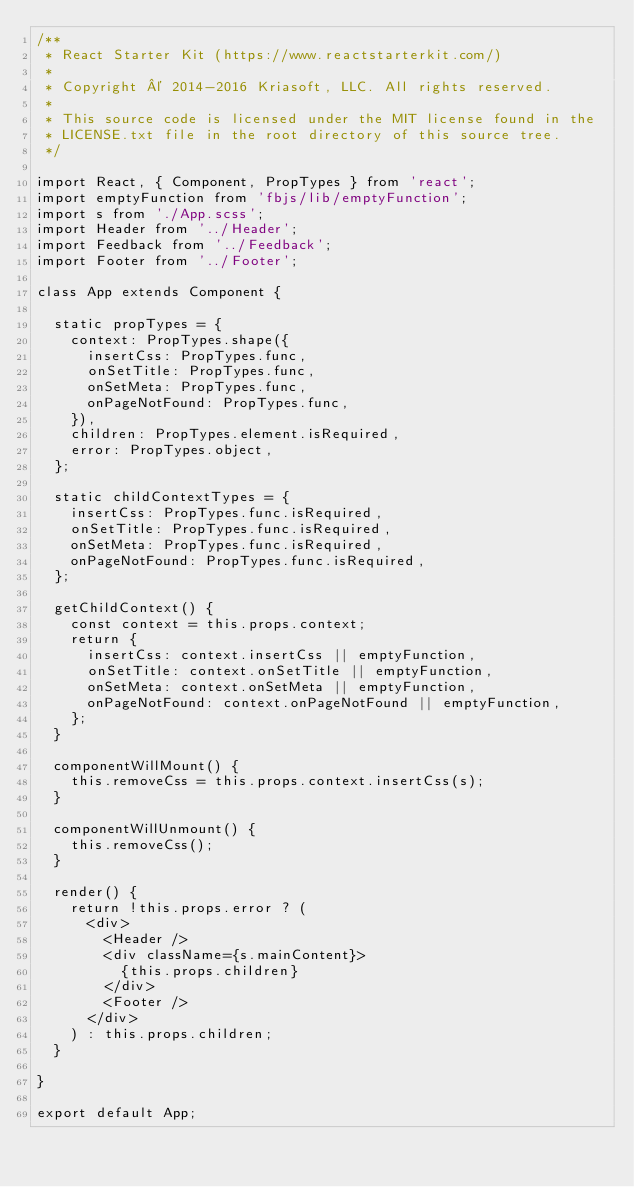<code> <loc_0><loc_0><loc_500><loc_500><_JavaScript_>/**
 * React Starter Kit (https://www.reactstarterkit.com/)
 *
 * Copyright © 2014-2016 Kriasoft, LLC. All rights reserved.
 *
 * This source code is licensed under the MIT license found in the
 * LICENSE.txt file in the root directory of this source tree.
 */

import React, { Component, PropTypes } from 'react';
import emptyFunction from 'fbjs/lib/emptyFunction';
import s from './App.scss';
import Header from '../Header';
import Feedback from '../Feedback';
import Footer from '../Footer';

class App extends Component {

  static propTypes = {
    context: PropTypes.shape({
      insertCss: PropTypes.func,
      onSetTitle: PropTypes.func,
      onSetMeta: PropTypes.func,
      onPageNotFound: PropTypes.func,
    }),
    children: PropTypes.element.isRequired,
    error: PropTypes.object,
  };

  static childContextTypes = {
    insertCss: PropTypes.func.isRequired,
    onSetTitle: PropTypes.func.isRequired,
    onSetMeta: PropTypes.func.isRequired,
    onPageNotFound: PropTypes.func.isRequired,
  };

  getChildContext() {
    const context = this.props.context;
    return {
      insertCss: context.insertCss || emptyFunction,
      onSetTitle: context.onSetTitle || emptyFunction,
      onSetMeta: context.onSetMeta || emptyFunction,
      onPageNotFound: context.onPageNotFound || emptyFunction,
    };
  }

  componentWillMount() {
    this.removeCss = this.props.context.insertCss(s);
  }

  componentWillUnmount() {
    this.removeCss();
  }

  render() {
    return !this.props.error ? (
      <div>
        <Header />
        <div className={s.mainContent}>
          {this.props.children}
        </div>
        <Footer />
      </div>
    ) : this.props.children;
  }

}

export default App;
</code> 